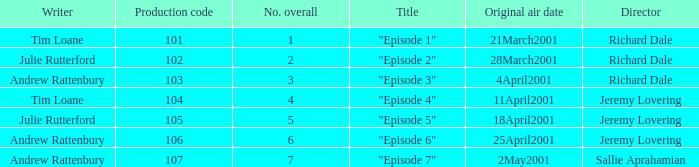When did the episodes first air that had a production code of 107? 2May2001. 